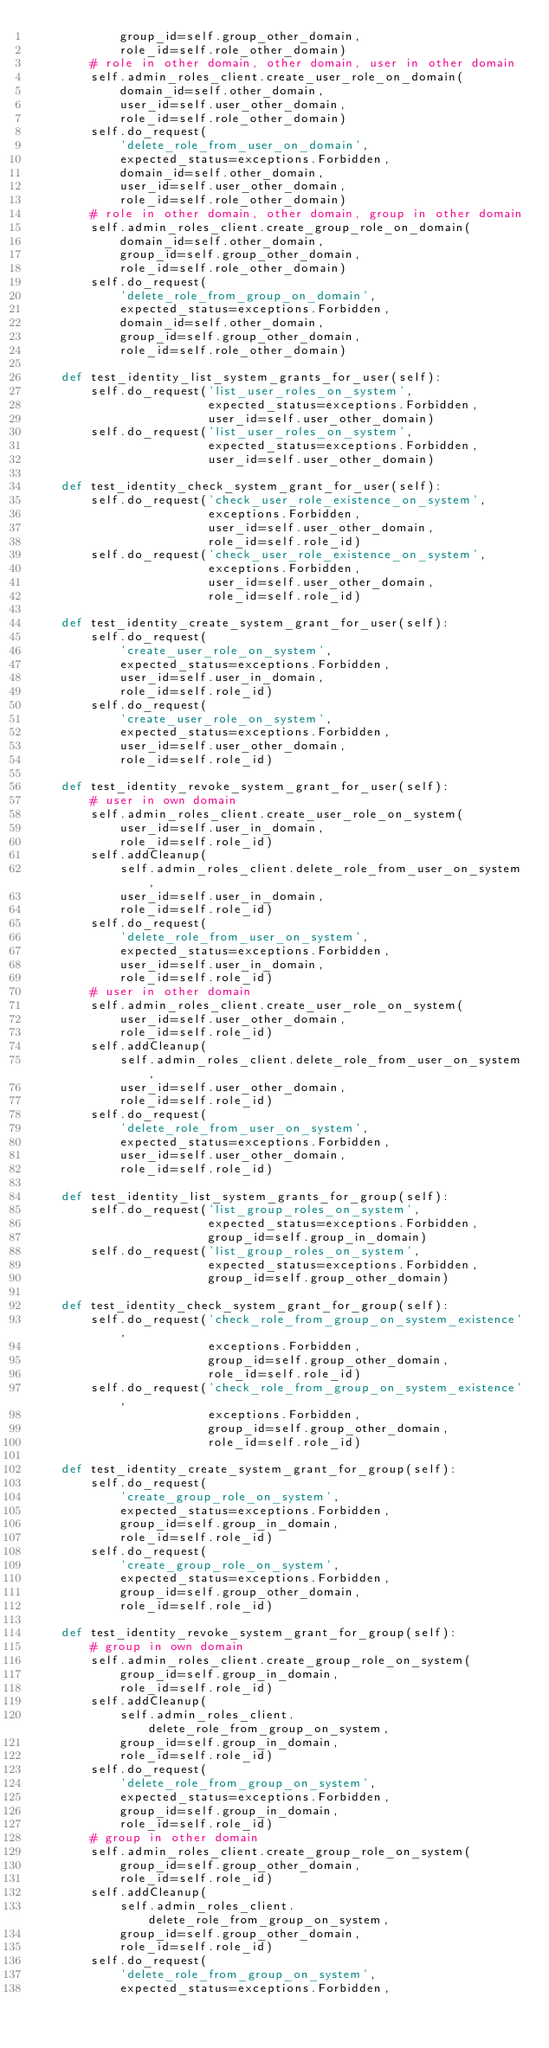Convert code to text. <code><loc_0><loc_0><loc_500><loc_500><_Python_>            group_id=self.group_other_domain,
            role_id=self.role_other_domain)
        # role in other domain, other domain, user in other domain
        self.admin_roles_client.create_user_role_on_domain(
            domain_id=self.other_domain,
            user_id=self.user_other_domain,
            role_id=self.role_other_domain)
        self.do_request(
            'delete_role_from_user_on_domain',
            expected_status=exceptions.Forbidden,
            domain_id=self.other_domain,
            user_id=self.user_other_domain,
            role_id=self.role_other_domain)
        # role in other domain, other domain, group in other domain
        self.admin_roles_client.create_group_role_on_domain(
            domain_id=self.other_domain,
            group_id=self.group_other_domain,
            role_id=self.role_other_domain)
        self.do_request(
            'delete_role_from_group_on_domain',
            expected_status=exceptions.Forbidden,
            domain_id=self.other_domain,
            group_id=self.group_other_domain,
            role_id=self.role_other_domain)

    def test_identity_list_system_grants_for_user(self):
        self.do_request('list_user_roles_on_system',
                        expected_status=exceptions.Forbidden,
                        user_id=self.user_other_domain)
        self.do_request('list_user_roles_on_system',
                        expected_status=exceptions.Forbidden,
                        user_id=self.user_other_domain)

    def test_identity_check_system_grant_for_user(self):
        self.do_request('check_user_role_existence_on_system',
                        exceptions.Forbidden,
                        user_id=self.user_other_domain,
                        role_id=self.role_id)
        self.do_request('check_user_role_existence_on_system',
                        exceptions.Forbidden,
                        user_id=self.user_other_domain,
                        role_id=self.role_id)

    def test_identity_create_system_grant_for_user(self):
        self.do_request(
            'create_user_role_on_system',
            expected_status=exceptions.Forbidden,
            user_id=self.user_in_domain,
            role_id=self.role_id)
        self.do_request(
            'create_user_role_on_system',
            expected_status=exceptions.Forbidden,
            user_id=self.user_other_domain,
            role_id=self.role_id)

    def test_identity_revoke_system_grant_for_user(self):
        # user in own domain
        self.admin_roles_client.create_user_role_on_system(
            user_id=self.user_in_domain,
            role_id=self.role_id)
        self.addCleanup(
            self.admin_roles_client.delete_role_from_user_on_system,
            user_id=self.user_in_domain,
            role_id=self.role_id)
        self.do_request(
            'delete_role_from_user_on_system',
            expected_status=exceptions.Forbidden,
            user_id=self.user_in_domain,
            role_id=self.role_id)
        # user in other domain
        self.admin_roles_client.create_user_role_on_system(
            user_id=self.user_other_domain,
            role_id=self.role_id)
        self.addCleanup(
            self.admin_roles_client.delete_role_from_user_on_system,
            user_id=self.user_other_domain,
            role_id=self.role_id)
        self.do_request(
            'delete_role_from_user_on_system',
            expected_status=exceptions.Forbidden,
            user_id=self.user_other_domain,
            role_id=self.role_id)

    def test_identity_list_system_grants_for_group(self):
        self.do_request('list_group_roles_on_system',
                        expected_status=exceptions.Forbidden,
                        group_id=self.group_in_domain)
        self.do_request('list_group_roles_on_system',
                        expected_status=exceptions.Forbidden,
                        group_id=self.group_other_domain)

    def test_identity_check_system_grant_for_group(self):
        self.do_request('check_role_from_group_on_system_existence',
                        exceptions.Forbidden,
                        group_id=self.group_other_domain,
                        role_id=self.role_id)
        self.do_request('check_role_from_group_on_system_existence',
                        exceptions.Forbidden,
                        group_id=self.group_other_domain,
                        role_id=self.role_id)

    def test_identity_create_system_grant_for_group(self):
        self.do_request(
            'create_group_role_on_system',
            expected_status=exceptions.Forbidden,
            group_id=self.group_in_domain,
            role_id=self.role_id)
        self.do_request(
            'create_group_role_on_system',
            expected_status=exceptions.Forbidden,
            group_id=self.group_other_domain,
            role_id=self.role_id)

    def test_identity_revoke_system_grant_for_group(self):
        # group in own domain
        self.admin_roles_client.create_group_role_on_system(
            group_id=self.group_in_domain,
            role_id=self.role_id)
        self.addCleanup(
            self.admin_roles_client.delete_role_from_group_on_system,
            group_id=self.group_in_domain,
            role_id=self.role_id)
        self.do_request(
            'delete_role_from_group_on_system',
            expected_status=exceptions.Forbidden,
            group_id=self.group_in_domain,
            role_id=self.role_id)
        # group in other domain
        self.admin_roles_client.create_group_role_on_system(
            group_id=self.group_other_domain,
            role_id=self.role_id)
        self.addCleanup(
            self.admin_roles_client.delete_role_from_group_on_system,
            group_id=self.group_other_domain,
            role_id=self.role_id)
        self.do_request(
            'delete_role_from_group_on_system',
            expected_status=exceptions.Forbidden,</code> 